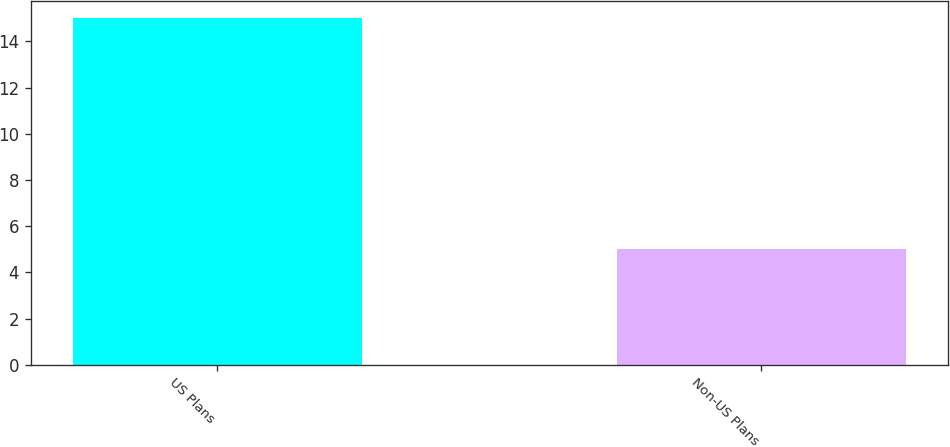Convert chart to OTSL. <chart><loc_0><loc_0><loc_500><loc_500><bar_chart><fcel>US Plans<fcel>Non-US Plans<nl><fcel>15<fcel>5<nl></chart> 